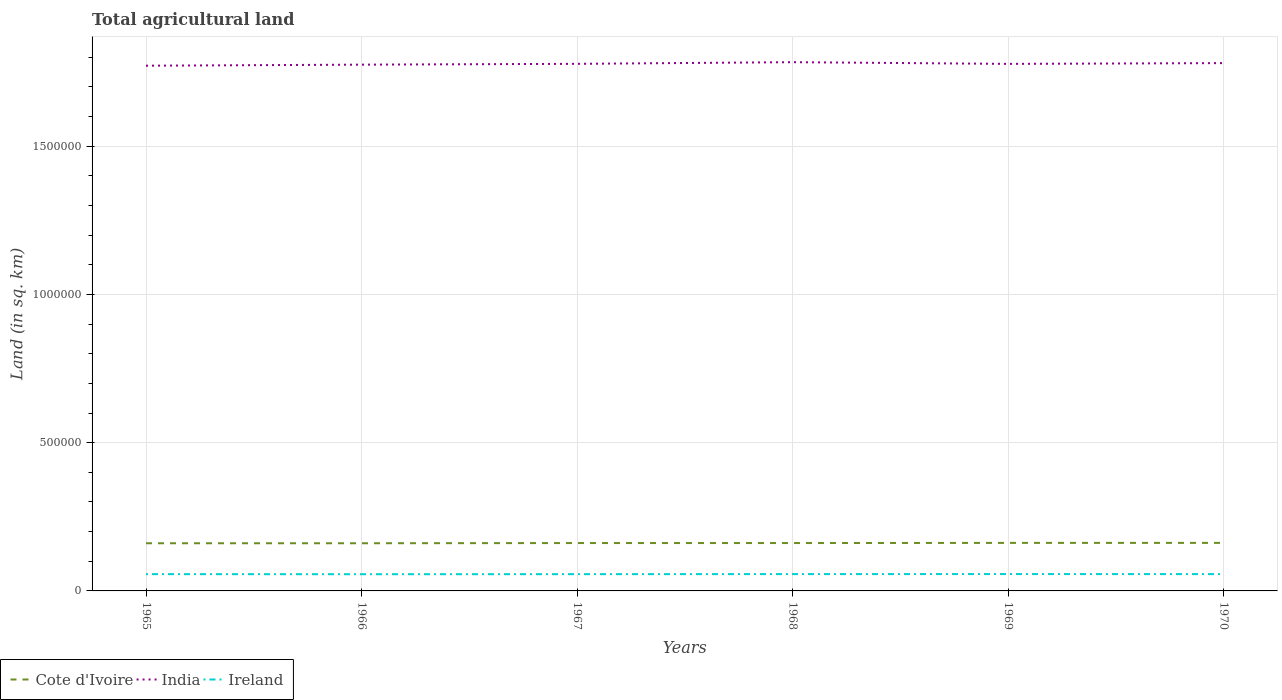Across all years, what is the maximum total agricultural land in Cote d'Ivoire?
Provide a short and direct response. 1.61e+05. In which year was the total agricultural land in India maximum?
Keep it short and to the point. 1965. What is the total total agricultural land in Ireland in the graph?
Offer a terse response. -290. What is the difference between the highest and the second highest total agricultural land in Ireland?
Offer a terse response. 560. How many years are there in the graph?
Offer a very short reply. 6. Where does the legend appear in the graph?
Make the answer very short. Bottom left. How are the legend labels stacked?
Your answer should be very brief. Horizontal. What is the title of the graph?
Keep it short and to the point. Total agricultural land. What is the label or title of the X-axis?
Provide a succinct answer. Years. What is the label or title of the Y-axis?
Your answer should be very brief. Land (in sq. km). What is the Land (in sq. km) of Cote d'Ivoire in 1965?
Keep it short and to the point. 1.61e+05. What is the Land (in sq. km) of India in 1965?
Provide a short and direct response. 1.77e+06. What is the Land (in sq. km) in Ireland in 1965?
Offer a terse response. 5.66e+04. What is the Land (in sq. km) in Cote d'Ivoire in 1966?
Provide a succinct answer. 1.61e+05. What is the Land (in sq. km) of India in 1966?
Your answer should be very brief. 1.78e+06. What is the Land (in sq. km) of Ireland in 1966?
Provide a succinct answer. 5.64e+04. What is the Land (in sq. km) in Cote d'Ivoire in 1967?
Your answer should be very brief. 1.62e+05. What is the Land (in sq. km) of India in 1967?
Ensure brevity in your answer.  1.78e+06. What is the Land (in sq. km) in Ireland in 1967?
Ensure brevity in your answer.  5.65e+04. What is the Land (in sq. km) in Cote d'Ivoire in 1968?
Your response must be concise. 1.62e+05. What is the Land (in sq. km) in India in 1968?
Provide a short and direct response. 1.78e+06. What is the Land (in sq. km) of Ireland in 1968?
Provide a short and direct response. 5.67e+04. What is the Land (in sq. km) in Cote d'Ivoire in 1969?
Make the answer very short. 1.62e+05. What is the Land (in sq. km) in India in 1969?
Ensure brevity in your answer.  1.78e+06. What is the Land (in sq. km) of Ireland in 1969?
Ensure brevity in your answer.  5.69e+04. What is the Land (in sq. km) in Cote d'Ivoire in 1970?
Offer a terse response. 1.62e+05. What is the Land (in sq. km) in India in 1970?
Your response must be concise. 1.78e+06. What is the Land (in sq. km) of Ireland in 1970?
Give a very brief answer. 5.67e+04. Across all years, what is the maximum Land (in sq. km) in Cote d'Ivoire?
Your answer should be very brief. 1.62e+05. Across all years, what is the maximum Land (in sq. km) of India?
Offer a terse response. 1.78e+06. Across all years, what is the maximum Land (in sq. km) in Ireland?
Provide a short and direct response. 5.69e+04. Across all years, what is the minimum Land (in sq. km) of Cote d'Ivoire?
Ensure brevity in your answer.  1.61e+05. Across all years, what is the minimum Land (in sq. km) of India?
Your response must be concise. 1.77e+06. Across all years, what is the minimum Land (in sq. km) of Ireland?
Your response must be concise. 5.64e+04. What is the total Land (in sq. km) in Cote d'Ivoire in the graph?
Keep it short and to the point. 9.69e+05. What is the total Land (in sq. km) in India in the graph?
Keep it short and to the point. 1.07e+07. What is the total Land (in sq. km) in Ireland in the graph?
Your response must be concise. 3.40e+05. What is the difference between the Land (in sq. km) of India in 1965 and that in 1966?
Provide a succinct answer. -3530. What is the difference between the Land (in sq. km) in Ireland in 1965 and that in 1966?
Your answer should be compact. 270. What is the difference between the Land (in sq. km) in Cote d'Ivoire in 1965 and that in 1967?
Ensure brevity in your answer.  -700. What is the difference between the Land (in sq. km) of India in 1965 and that in 1967?
Keep it short and to the point. -6300. What is the difference between the Land (in sq. km) in Ireland in 1965 and that in 1967?
Your answer should be compact. 80. What is the difference between the Land (in sq. km) in Cote d'Ivoire in 1965 and that in 1968?
Ensure brevity in your answer.  -700. What is the difference between the Land (in sq. km) in India in 1965 and that in 1968?
Give a very brief answer. -1.19e+04. What is the difference between the Land (in sq. km) of Ireland in 1965 and that in 1968?
Keep it short and to the point. -120. What is the difference between the Land (in sq. km) of Cote d'Ivoire in 1965 and that in 1969?
Keep it short and to the point. -1200. What is the difference between the Land (in sq. km) in India in 1965 and that in 1969?
Provide a short and direct response. -6150. What is the difference between the Land (in sq. km) of Ireland in 1965 and that in 1969?
Your response must be concise. -290. What is the difference between the Land (in sq. km) of Cote d'Ivoire in 1965 and that in 1970?
Give a very brief answer. -1200. What is the difference between the Land (in sq. km) in India in 1965 and that in 1970?
Your response must be concise. -8750. What is the difference between the Land (in sq. km) in Ireland in 1965 and that in 1970?
Ensure brevity in your answer.  -50. What is the difference between the Land (in sq. km) in Cote d'Ivoire in 1966 and that in 1967?
Your answer should be very brief. -700. What is the difference between the Land (in sq. km) of India in 1966 and that in 1967?
Give a very brief answer. -2770. What is the difference between the Land (in sq. km) of Ireland in 1966 and that in 1967?
Your response must be concise. -190. What is the difference between the Land (in sq. km) in Cote d'Ivoire in 1966 and that in 1968?
Provide a short and direct response. -700. What is the difference between the Land (in sq. km) in India in 1966 and that in 1968?
Provide a succinct answer. -8340. What is the difference between the Land (in sq. km) of Ireland in 1966 and that in 1968?
Make the answer very short. -390. What is the difference between the Land (in sq. km) in Cote d'Ivoire in 1966 and that in 1969?
Your answer should be compact. -1200. What is the difference between the Land (in sq. km) in India in 1966 and that in 1969?
Provide a short and direct response. -2620. What is the difference between the Land (in sq. km) in Ireland in 1966 and that in 1969?
Your answer should be very brief. -560. What is the difference between the Land (in sq. km) in Cote d'Ivoire in 1966 and that in 1970?
Your answer should be very brief. -1200. What is the difference between the Land (in sq. km) of India in 1966 and that in 1970?
Your answer should be compact. -5220. What is the difference between the Land (in sq. km) in Ireland in 1966 and that in 1970?
Provide a succinct answer. -320. What is the difference between the Land (in sq. km) of India in 1967 and that in 1968?
Your answer should be very brief. -5570. What is the difference between the Land (in sq. km) of Ireland in 1967 and that in 1968?
Your response must be concise. -200. What is the difference between the Land (in sq. km) in Cote d'Ivoire in 1967 and that in 1969?
Your answer should be very brief. -500. What is the difference between the Land (in sq. km) in India in 1967 and that in 1969?
Offer a very short reply. 150. What is the difference between the Land (in sq. km) of Ireland in 1967 and that in 1969?
Your response must be concise. -370. What is the difference between the Land (in sq. km) of Cote d'Ivoire in 1967 and that in 1970?
Give a very brief answer. -500. What is the difference between the Land (in sq. km) of India in 1967 and that in 1970?
Your answer should be compact. -2450. What is the difference between the Land (in sq. km) of Ireland in 1967 and that in 1970?
Your response must be concise. -130. What is the difference between the Land (in sq. km) in Cote d'Ivoire in 1968 and that in 1969?
Your answer should be compact. -500. What is the difference between the Land (in sq. km) of India in 1968 and that in 1969?
Give a very brief answer. 5720. What is the difference between the Land (in sq. km) in Ireland in 1968 and that in 1969?
Provide a short and direct response. -170. What is the difference between the Land (in sq. km) in Cote d'Ivoire in 1968 and that in 1970?
Ensure brevity in your answer.  -500. What is the difference between the Land (in sq. km) in India in 1968 and that in 1970?
Offer a very short reply. 3120. What is the difference between the Land (in sq. km) of Ireland in 1968 and that in 1970?
Your answer should be compact. 70. What is the difference between the Land (in sq. km) in India in 1969 and that in 1970?
Give a very brief answer. -2600. What is the difference between the Land (in sq. km) of Ireland in 1969 and that in 1970?
Provide a short and direct response. 240. What is the difference between the Land (in sq. km) in Cote d'Ivoire in 1965 and the Land (in sq. km) in India in 1966?
Make the answer very short. -1.61e+06. What is the difference between the Land (in sq. km) in Cote d'Ivoire in 1965 and the Land (in sq. km) in Ireland in 1966?
Your answer should be compact. 1.04e+05. What is the difference between the Land (in sq. km) of India in 1965 and the Land (in sq. km) of Ireland in 1966?
Your answer should be compact. 1.72e+06. What is the difference between the Land (in sq. km) of Cote d'Ivoire in 1965 and the Land (in sq. km) of India in 1967?
Give a very brief answer. -1.62e+06. What is the difference between the Land (in sq. km) of Cote d'Ivoire in 1965 and the Land (in sq. km) of Ireland in 1967?
Ensure brevity in your answer.  1.04e+05. What is the difference between the Land (in sq. km) of India in 1965 and the Land (in sq. km) of Ireland in 1967?
Provide a succinct answer. 1.72e+06. What is the difference between the Land (in sq. km) of Cote d'Ivoire in 1965 and the Land (in sq. km) of India in 1968?
Your answer should be very brief. -1.62e+06. What is the difference between the Land (in sq. km) of Cote d'Ivoire in 1965 and the Land (in sq. km) of Ireland in 1968?
Provide a short and direct response. 1.04e+05. What is the difference between the Land (in sq. km) in India in 1965 and the Land (in sq. km) in Ireland in 1968?
Give a very brief answer. 1.72e+06. What is the difference between the Land (in sq. km) in Cote d'Ivoire in 1965 and the Land (in sq. km) in India in 1969?
Provide a succinct answer. -1.62e+06. What is the difference between the Land (in sq. km) in Cote d'Ivoire in 1965 and the Land (in sq. km) in Ireland in 1969?
Keep it short and to the point. 1.04e+05. What is the difference between the Land (in sq. km) in India in 1965 and the Land (in sq. km) in Ireland in 1969?
Provide a succinct answer. 1.71e+06. What is the difference between the Land (in sq. km) of Cote d'Ivoire in 1965 and the Land (in sq. km) of India in 1970?
Make the answer very short. -1.62e+06. What is the difference between the Land (in sq. km) in Cote d'Ivoire in 1965 and the Land (in sq. km) in Ireland in 1970?
Your answer should be very brief. 1.04e+05. What is the difference between the Land (in sq. km) of India in 1965 and the Land (in sq. km) of Ireland in 1970?
Make the answer very short. 1.72e+06. What is the difference between the Land (in sq. km) in Cote d'Ivoire in 1966 and the Land (in sq. km) in India in 1967?
Your response must be concise. -1.62e+06. What is the difference between the Land (in sq. km) of Cote d'Ivoire in 1966 and the Land (in sq. km) of Ireland in 1967?
Give a very brief answer. 1.04e+05. What is the difference between the Land (in sq. km) of India in 1966 and the Land (in sq. km) of Ireland in 1967?
Ensure brevity in your answer.  1.72e+06. What is the difference between the Land (in sq. km) of Cote d'Ivoire in 1966 and the Land (in sq. km) of India in 1968?
Provide a short and direct response. -1.62e+06. What is the difference between the Land (in sq. km) of Cote d'Ivoire in 1966 and the Land (in sq. km) of Ireland in 1968?
Offer a terse response. 1.04e+05. What is the difference between the Land (in sq. km) in India in 1966 and the Land (in sq. km) in Ireland in 1968?
Ensure brevity in your answer.  1.72e+06. What is the difference between the Land (in sq. km) of Cote d'Ivoire in 1966 and the Land (in sq. km) of India in 1969?
Offer a very short reply. -1.62e+06. What is the difference between the Land (in sq. km) of Cote d'Ivoire in 1966 and the Land (in sq. km) of Ireland in 1969?
Make the answer very short. 1.04e+05. What is the difference between the Land (in sq. km) in India in 1966 and the Land (in sq. km) in Ireland in 1969?
Your answer should be compact. 1.72e+06. What is the difference between the Land (in sq. km) in Cote d'Ivoire in 1966 and the Land (in sq. km) in India in 1970?
Your response must be concise. -1.62e+06. What is the difference between the Land (in sq. km) of Cote d'Ivoire in 1966 and the Land (in sq. km) of Ireland in 1970?
Provide a succinct answer. 1.04e+05. What is the difference between the Land (in sq. km) of India in 1966 and the Land (in sq. km) of Ireland in 1970?
Your answer should be very brief. 1.72e+06. What is the difference between the Land (in sq. km) in Cote d'Ivoire in 1967 and the Land (in sq. km) in India in 1968?
Your answer should be very brief. -1.62e+06. What is the difference between the Land (in sq. km) of Cote d'Ivoire in 1967 and the Land (in sq. km) of Ireland in 1968?
Your answer should be very brief. 1.05e+05. What is the difference between the Land (in sq. km) of India in 1967 and the Land (in sq. km) of Ireland in 1968?
Give a very brief answer. 1.72e+06. What is the difference between the Land (in sq. km) in Cote d'Ivoire in 1967 and the Land (in sq. km) in India in 1969?
Make the answer very short. -1.62e+06. What is the difference between the Land (in sq. km) of Cote d'Ivoire in 1967 and the Land (in sq. km) of Ireland in 1969?
Give a very brief answer. 1.05e+05. What is the difference between the Land (in sq. km) in India in 1967 and the Land (in sq. km) in Ireland in 1969?
Provide a succinct answer. 1.72e+06. What is the difference between the Land (in sq. km) in Cote d'Ivoire in 1967 and the Land (in sq. km) in India in 1970?
Offer a terse response. -1.62e+06. What is the difference between the Land (in sq. km) of Cote d'Ivoire in 1967 and the Land (in sq. km) of Ireland in 1970?
Your answer should be compact. 1.05e+05. What is the difference between the Land (in sq. km) in India in 1967 and the Land (in sq. km) in Ireland in 1970?
Your answer should be very brief. 1.72e+06. What is the difference between the Land (in sq. km) in Cote d'Ivoire in 1968 and the Land (in sq. km) in India in 1969?
Provide a succinct answer. -1.62e+06. What is the difference between the Land (in sq. km) in Cote d'Ivoire in 1968 and the Land (in sq. km) in Ireland in 1969?
Offer a very short reply. 1.05e+05. What is the difference between the Land (in sq. km) in India in 1968 and the Land (in sq. km) in Ireland in 1969?
Your answer should be very brief. 1.73e+06. What is the difference between the Land (in sq. km) of Cote d'Ivoire in 1968 and the Land (in sq. km) of India in 1970?
Your answer should be very brief. -1.62e+06. What is the difference between the Land (in sq. km) of Cote d'Ivoire in 1968 and the Land (in sq. km) of Ireland in 1970?
Your answer should be very brief. 1.05e+05. What is the difference between the Land (in sq. km) of India in 1968 and the Land (in sq. km) of Ireland in 1970?
Provide a succinct answer. 1.73e+06. What is the difference between the Land (in sq. km) of Cote d'Ivoire in 1969 and the Land (in sq. km) of India in 1970?
Offer a terse response. -1.62e+06. What is the difference between the Land (in sq. km) in Cote d'Ivoire in 1969 and the Land (in sq. km) in Ireland in 1970?
Your answer should be very brief. 1.05e+05. What is the difference between the Land (in sq. km) of India in 1969 and the Land (in sq. km) of Ireland in 1970?
Provide a succinct answer. 1.72e+06. What is the average Land (in sq. km) of Cote d'Ivoire per year?
Offer a terse response. 1.61e+05. What is the average Land (in sq. km) of India per year?
Provide a short and direct response. 1.78e+06. What is the average Land (in sq. km) of Ireland per year?
Your answer should be very brief. 5.66e+04. In the year 1965, what is the difference between the Land (in sq. km) of Cote d'Ivoire and Land (in sq. km) of India?
Make the answer very short. -1.61e+06. In the year 1965, what is the difference between the Land (in sq. km) in Cote d'Ivoire and Land (in sq. km) in Ireland?
Give a very brief answer. 1.04e+05. In the year 1965, what is the difference between the Land (in sq. km) in India and Land (in sq. km) in Ireland?
Give a very brief answer. 1.72e+06. In the year 1966, what is the difference between the Land (in sq. km) in Cote d'Ivoire and Land (in sq. km) in India?
Give a very brief answer. -1.61e+06. In the year 1966, what is the difference between the Land (in sq. km) of Cote d'Ivoire and Land (in sq. km) of Ireland?
Offer a very short reply. 1.04e+05. In the year 1966, what is the difference between the Land (in sq. km) in India and Land (in sq. km) in Ireland?
Ensure brevity in your answer.  1.72e+06. In the year 1967, what is the difference between the Land (in sq. km) of Cote d'Ivoire and Land (in sq. km) of India?
Offer a terse response. -1.62e+06. In the year 1967, what is the difference between the Land (in sq. km) of Cote d'Ivoire and Land (in sq. km) of Ireland?
Keep it short and to the point. 1.05e+05. In the year 1967, what is the difference between the Land (in sq. km) of India and Land (in sq. km) of Ireland?
Give a very brief answer. 1.72e+06. In the year 1968, what is the difference between the Land (in sq. km) of Cote d'Ivoire and Land (in sq. km) of India?
Provide a succinct answer. -1.62e+06. In the year 1968, what is the difference between the Land (in sq. km) in Cote d'Ivoire and Land (in sq. km) in Ireland?
Give a very brief answer. 1.05e+05. In the year 1968, what is the difference between the Land (in sq. km) of India and Land (in sq. km) of Ireland?
Provide a short and direct response. 1.73e+06. In the year 1969, what is the difference between the Land (in sq. km) in Cote d'Ivoire and Land (in sq. km) in India?
Provide a short and direct response. -1.62e+06. In the year 1969, what is the difference between the Land (in sq. km) in Cote d'Ivoire and Land (in sq. km) in Ireland?
Offer a terse response. 1.05e+05. In the year 1969, what is the difference between the Land (in sq. km) of India and Land (in sq. km) of Ireland?
Provide a short and direct response. 1.72e+06. In the year 1970, what is the difference between the Land (in sq. km) of Cote d'Ivoire and Land (in sq. km) of India?
Your response must be concise. -1.62e+06. In the year 1970, what is the difference between the Land (in sq. km) of Cote d'Ivoire and Land (in sq. km) of Ireland?
Your response must be concise. 1.05e+05. In the year 1970, what is the difference between the Land (in sq. km) of India and Land (in sq. km) of Ireland?
Give a very brief answer. 1.72e+06. What is the ratio of the Land (in sq. km) in India in 1965 to that in 1966?
Ensure brevity in your answer.  1. What is the ratio of the Land (in sq. km) in Ireland in 1965 to that in 1966?
Offer a very short reply. 1. What is the ratio of the Land (in sq. km) in Cote d'Ivoire in 1965 to that in 1967?
Your answer should be compact. 1. What is the ratio of the Land (in sq. km) in Ireland in 1965 to that in 1967?
Offer a very short reply. 1. What is the ratio of the Land (in sq. km) of India in 1965 to that in 1968?
Offer a very short reply. 0.99. What is the ratio of the Land (in sq. km) of India in 1965 to that in 1969?
Make the answer very short. 1. What is the ratio of the Land (in sq. km) of India in 1965 to that in 1970?
Keep it short and to the point. 1. What is the ratio of the Land (in sq. km) of India in 1966 to that in 1967?
Make the answer very short. 1. What is the ratio of the Land (in sq. km) of India in 1966 to that in 1968?
Your response must be concise. 1. What is the ratio of the Land (in sq. km) in Ireland in 1966 to that in 1968?
Your answer should be compact. 0.99. What is the ratio of the Land (in sq. km) of Cote d'Ivoire in 1966 to that in 1969?
Offer a terse response. 0.99. What is the ratio of the Land (in sq. km) of Ireland in 1966 to that in 1969?
Your answer should be compact. 0.99. What is the ratio of the Land (in sq. km) in Cote d'Ivoire in 1966 to that in 1970?
Your answer should be compact. 0.99. What is the ratio of the Land (in sq. km) in India in 1967 to that in 1968?
Offer a terse response. 1. What is the ratio of the Land (in sq. km) in Ireland in 1967 to that in 1968?
Your answer should be compact. 1. What is the ratio of the Land (in sq. km) of Ireland in 1967 to that in 1969?
Provide a short and direct response. 0.99. What is the ratio of the Land (in sq. km) in India in 1967 to that in 1970?
Make the answer very short. 1. What is the ratio of the Land (in sq. km) in Cote d'Ivoire in 1968 to that in 1969?
Offer a very short reply. 1. What is the ratio of the Land (in sq. km) in India in 1968 to that in 1969?
Offer a terse response. 1. What is the ratio of the Land (in sq. km) in India in 1968 to that in 1970?
Keep it short and to the point. 1. What is the ratio of the Land (in sq. km) of India in 1969 to that in 1970?
Your response must be concise. 1. What is the difference between the highest and the second highest Land (in sq. km) of Cote d'Ivoire?
Give a very brief answer. 0. What is the difference between the highest and the second highest Land (in sq. km) in India?
Keep it short and to the point. 3120. What is the difference between the highest and the second highest Land (in sq. km) of Ireland?
Give a very brief answer. 170. What is the difference between the highest and the lowest Land (in sq. km) of Cote d'Ivoire?
Make the answer very short. 1200. What is the difference between the highest and the lowest Land (in sq. km) in India?
Your response must be concise. 1.19e+04. What is the difference between the highest and the lowest Land (in sq. km) of Ireland?
Provide a succinct answer. 560. 